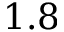Convert formula to latex. <formula><loc_0><loc_0><loc_500><loc_500>1 . 8</formula> 